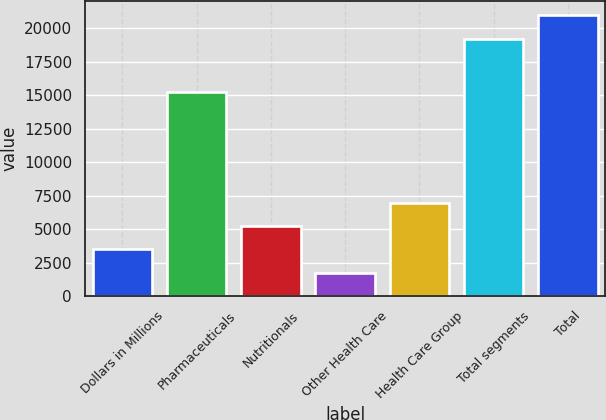<chart> <loc_0><loc_0><loc_500><loc_500><bar_chart><fcel>Dollars in Millions<fcel>Pharmaceuticals<fcel>Nutritionals<fcel>Other Health Care<fcel>Health Care Group<fcel>Total segments<fcel>Total<nl><fcel>3493.9<fcel>15254<fcel>5239.8<fcel>1748<fcel>6985.7<fcel>19207<fcel>20952.9<nl></chart> 